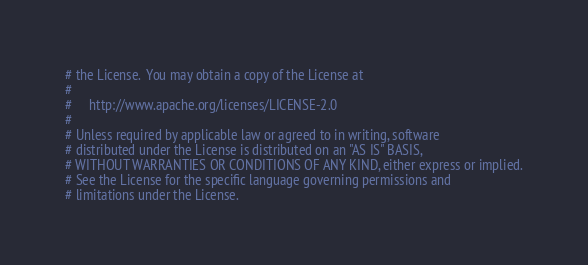Convert code to text. <code><loc_0><loc_0><loc_500><loc_500><_Python_># the License.  You may obtain a copy of the License at
#
#     http://www.apache.org/licenses/LICENSE-2.0
#
# Unless required by applicable law or agreed to in writing, software
# distributed under the License is distributed on an "AS IS" BASIS,
# WITHOUT WARRANTIES OR CONDITIONS OF ANY KIND, either express or implied.
# See the License for the specific language governing permissions and
# limitations under the License.
</code> 